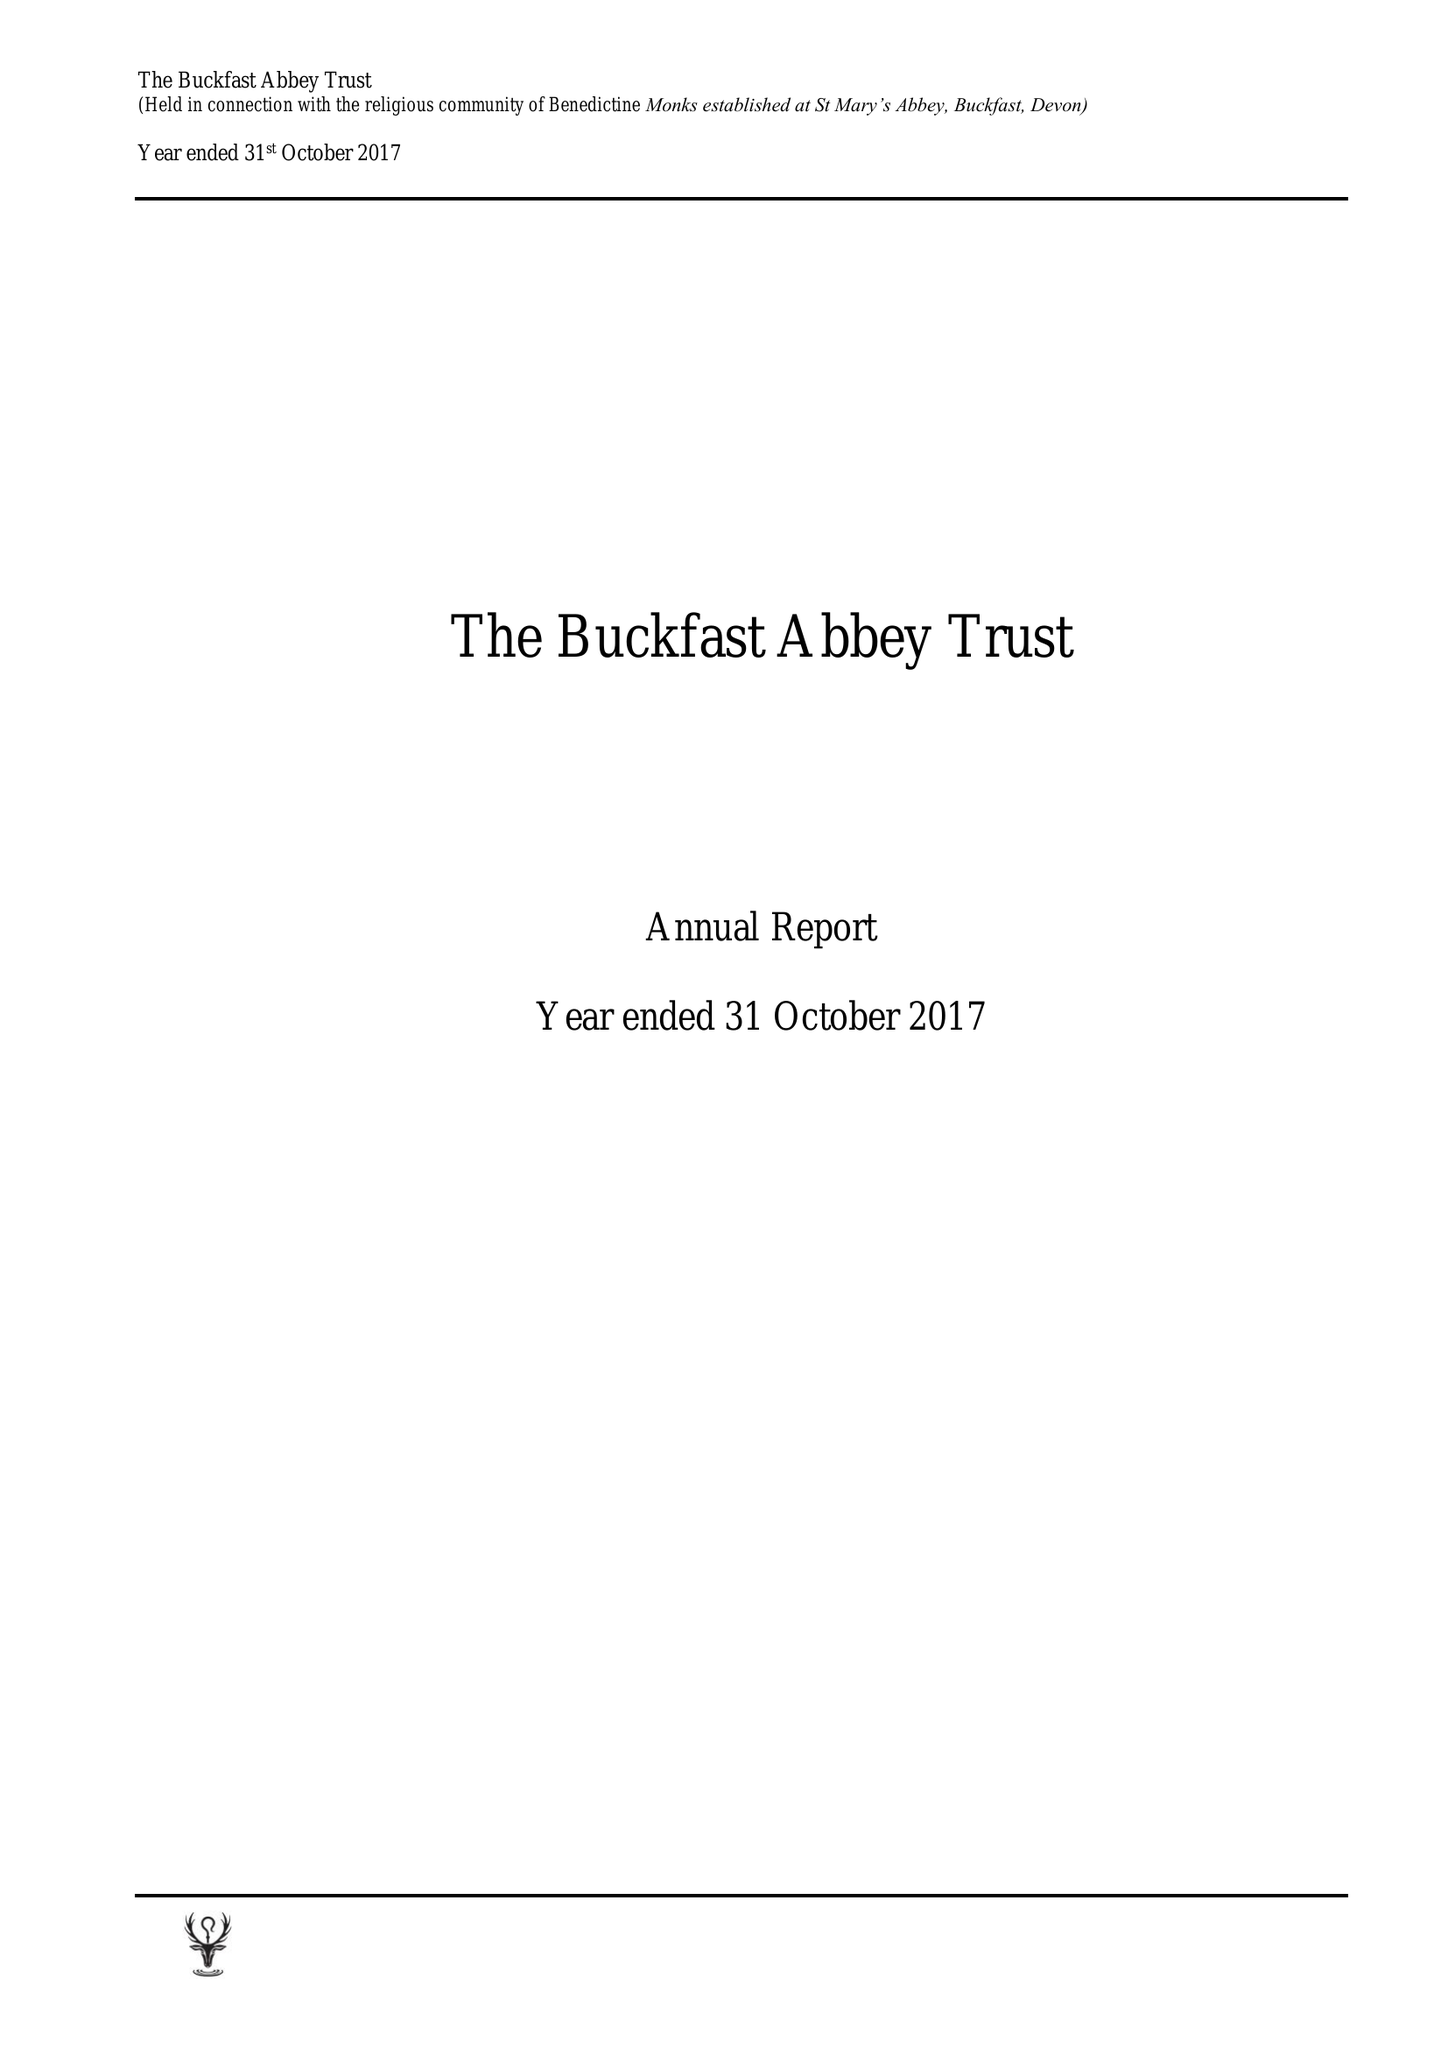What is the value for the charity_name?
Answer the question using a single word or phrase. Buckfast Abbey Trust (Held Icw The Religious Community Of Benedictine Monks Established At St Marys Abbey Buckfast, Devon) 